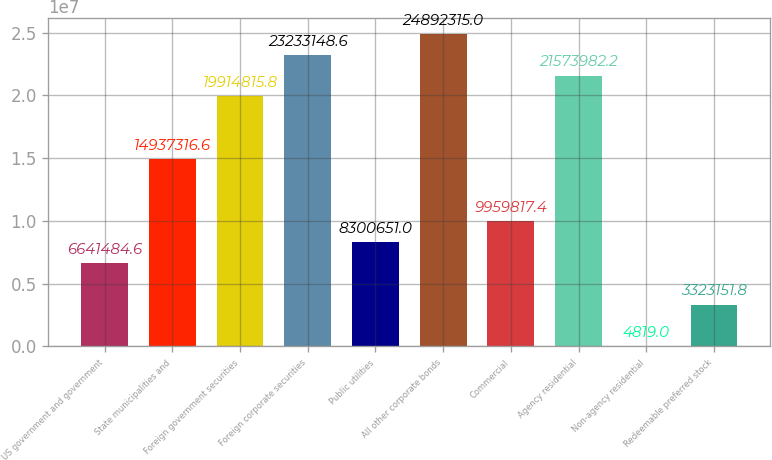<chart> <loc_0><loc_0><loc_500><loc_500><bar_chart><fcel>US government and government<fcel>State municipalities and<fcel>Foreign government securities<fcel>Foreign corporate securities<fcel>Public utilities<fcel>All other corporate bonds<fcel>Commercial<fcel>Agency residential<fcel>Non-agency residential<fcel>Redeemable preferred stock<nl><fcel>6.64148e+06<fcel>1.49373e+07<fcel>1.99148e+07<fcel>2.32331e+07<fcel>8.30065e+06<fcel>2.48923e+07<fcel>9.95982e+06<fcel>2.1574e+07<fcel>4819<fcel>3.32315e+06<nl></chart> 